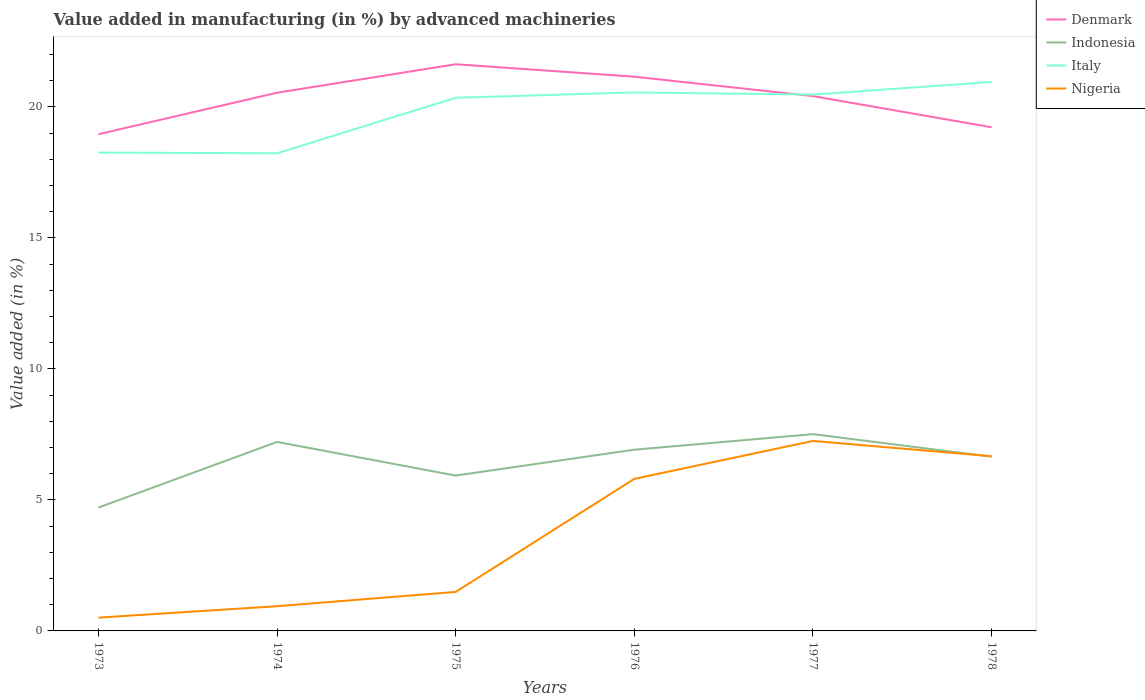Is the number of lines equal to the number of legend labels?
Your answer should be very brief. Yes. Across all years, what is the maximum percentage of value added in manufacturing by advanced machineries in Italy?
Keep it short and to the point. 18.23. What is the total percentage of value added in manufacturing by advanced machineries in Indonesia in the graph?
Provide a succinct answer. 0.27. What is the difference between the highest and the second highest percentage of value added in manufacturing by advanced machineries in Indonesia?
Offer a very short reply. 2.8. What is the difference between the highest and the lowest percentage of value added in manufacturing by advanced machineries in Denmark?
Your answer should be very brief. 4. Is the percentage of value added in manufacturing by advanced machineries in Italy strictly greater than the percentage of value added in manufacturing by advanced machineries in Nigeria over the years?
Keep it short and to the point. No. How many lines are there?
Give a very brief answer. 4. What is the difference between two consecutive major ticks on the Y-axis?
Offer a very short reply. 5. Does the graph contain any zero values?
Give a very brief answer. No. Does the graph contain grids?
Provide a succinct answer. No. Where does the legend appear in the graph?
Your answer should be compact. Top right. What is the title of the graph?
Provide a succinct answer. Value added in manufacturing (in %) by advanced machineries. Does "Mozambique" appear as one of the legend labels in the graph?
Make the answer very short. No. What is the label or title of the Y-axis?
Offer a very short reply. Value added (in %). What is the Value added (in %) in Denmark in 1973?
Your answer should be very brief. 18.95. What is the Value added (in %) in Indonesia in 1973?
Give a very brief answer. 4.71. What is the Value added (in %) of Italy in 1973?
Provide a succinct answer. 18.25. What is the Value added (in %) in Nigeria in 1973?
Your answer should be compact. 0.51. What is the Value added (in %) of Denmark in 1974?
Provide a succinct answer. 20.54. What is the Value added (in %) of Indonesia in 1974?
Offer a very short reply. 7.21. What is the Value added (in %) of Italy in 1974?
Provide a short and direct response. 18.23. What is the Value added (in %) of Nigeria in 1974?
Provide a succinct answer. 0.94. What is the Value added (in %) in Denmark in 1975?
Provide a short and direct response. 21.62. What is the Value added (in %) of Indonesia in 1975?
Offer a very short reply. 5.93. What is the Value added (in %) in Italy in 1975?
Your response must be concise. 20.34. What is the Value added (in %) in Nigeria in 1975?
Your answer should be compact. 1.49. What is the Value added (in %) of Denmark in 1976?
Keep it short and to the point. 21.15. What is the Value added (in %) of Indonesia in 1976?
Offer a terse response. 6.92. What is the Value added (in %) in Italy in 1976?
Provide a succinct answer. 20.55. What is the Value added (in %) of Nigeria in 1976?
Offer a terse response. 5.8. What is the Value added (in %) in Denmark in 1977?
Your response must be concise. 20.41. What is the Value added (in %) in Indonesia in 1977?
Ensure brevity in your answer.  7.51. What is the Value added (in %) in Italy in 1977?
Offer a terse response. 20.47. What is the Value added (in %) of Nigeria in 1977?
Ensure brevity in your answer.  7.25. What is the Value added (in %) of Denmark in 1978?
Your answer should be compact. 19.22. What is the Value added (in %) in Indonesia in 1978?
Offer a terse response. 6.65. What is the Value added (in %) of Italy in 1978?
Offer a very short reply. 20.95. What is the Value added (in %) of Nigeria in 1978?
Offer a very short reply. 6.67. Across all years, what is the maximum Value added (in %) in Denmark?
Your answer should be very brief. 21.62. Across all years, what is the maximum Value added (in %) in Indonesia?
Your answer should be very brief. 7.51. Across all years, what is the maximum Value added (in %) in Italy?
Keep it short and to the point. 20.95. Across all years, what is the maximum Value added (in %) in Nigeria?
Offer a very short reply. 7.25. Across all years, what is the minimum Value added (in %) in Denmark?
Ensure brevity in your answer.  18.95. Across all years, what is the minimum Value added (in %) of Indonesia?
Ensure brevity in your answer.  4.71. Across all years, what is the minimum Value added (in %) of Italy?
Provide a short and direct response. 18.23. Across all years, what is the minimum Value added (in %) in Nigeria?
Provide a succinct answer. 0.51. What is the total Value added (in %) in Denmark in the graph?
Give a very brief answer. 121.89. What is the total Value added (in %) of Indonesia in the graph?
Offer a terse response. 38.92. What is the total Value added (in %) in Italy in the graph?
Provide a succinct answer. 118.79. What is the total Value added (in %) in Nigeria in the graph?
Keep it short and to the point. 22.66. What is the difference between the Value added (in %) in Denmark in 1973 and that in 1974?
Provide a succinct answer. -1.58. What is the difference between the Value added (in %) in Indonesia in 1973 and that in 1974?
Make the answer very short. -2.51. What is the difference between the Value added (in %) of Italy in 1973 and that in 1974?
Provide a short and direct response. 0.03. What is the difference between the Value added (in %) of Nigeria in 1973 and that in 1974?
Make the answer very short. -0.44. What is the difference between the Value added (in %) of Denmark in 1973 and that in 1975?
Your answer should be very brief. -2.67. What is the difference between the Value added (in %) of Indonesia in 1973 and that in 1975?
Ensure brevity in your answer.  -1.22. What is the difference between the Value added (in %) in Italy in 1973 and that in 1975?
Offer a very short reply. -2.09. What is the difference between the Value added (in %) in Nigeria in 1973 and that in 1975?
Your response must be concise. -0.98. What is the difference between the Value added (in %) in Denmark in 1973 and that in 1976?
Offer a very short reply. -2.19. What is the difference between the Value added (in %) in Indonesia in 1973 and that in 1976?
Give a very brief answer. -2.21. What is the difference between the Value added (in %) of Italy in 1973 and that in 1976?
Your response must be concise. -2.29. What is the difference between the Value added (in %) of Nigeria in 1973 and that in 1976?
Your response must be concise. -5.3. What is the difference between the Value added (in %) in Denmark in 1973 and that in 1977?
Offer a terse response. -1.45. What is the difference between the Value added (in %) in Indonesia in 1973 and that in 1977?
Provide a succinct answer. -2.8. What is the difference between the Value added (in %) in Italy in 1973 and that in 1977?
Provide a short and direct response. -2.21. What is the difference between the Value added (in %) in Nigeria in 1973 and that in 1977?
Your answer should be compact. -6.74. What is the difference between the Value added (in %) in Denmark in 1973 and that in 1978?
Offer a very short reply. -0.26. What is the difference between the Value added (in %) in Indonesia in 1973 and that in 1978?
Keep it short and to the point. -1.94. What is the difference between the Value added (in %) in Italy in 1973 and that in 1978?
Offer a very short reply. -2.7. What is the difference between the Value added (in %) of Nigeria in 1973 and that in 1978?
Keep it short and to the point. -6.16. What is the difference between the Value added (in %) in Denmark in 1974 and that in 1975?
Provide a succinct answer. -1.09. What is the difference between the Value added (in %) of Indonesia in 1974 and that in 1975?
Give a very brief answer. 1.28. What is the difference between the Value added (in %) in Italy in 1974 and that in 1975?
Offer a very short reply. -2.12. What is the difference between the Value added (in %) in Nigeria in 1974 and that in 1975?
Make the answer very short. -0.55. What is the difference between the Value added (in %) of Denmark in 1974 and that in 1976?
Ensure brevity in your answer.  -0.61. What is the difference between the Value added (in %) of Indonesia in 1974 and that in 1976?
Your response must be concise. 0.3. What is the difference between the Value added (in %) of Italy in 1974 and that in 1976?
Give a very brief answer. -2.32. What is the difference between the Value added (in %) of Nigeria in 1974 and that in 1976?
Provide a short and direct response. -4.86. What is the difference between the Value added (in %) in Denmark in 1974 and that in 1977?
Give a very brief answer. 0.13. What is the difference between the Value added (in %) in Indonesia in 1974 and that in 1977?
Provide a short and direct response. -0.3. What is the difference between the Value added (in %) in Italy in 1974 and that in 1977?
Give a very brief answer. -2.24. What is the difference between the Value added (in %) in Nigeria in 1974 and that in 1977?
Make the answer very short. -6.31. What is the difference between the Value added (in %) of Denmark in 1974 and that in 1978?
Your answer should be compact. 1.32. What is the difference between the Value added (in %) of Indonesia in 1974 and that in 1978?
Keep it short and to the point. 0.56. What is the difference between the Value added (in %) of Italy in 1974 and that in 1978?
Give a very brief answer. -2.72. What is the difference between the Value added (in %) in Nigeria in 1974 and that in 1978?
Give a very brief answer. -5.72. What is the difference between the Value added (in %) of Denmark in 1975 and that in 1976?
Provide a succinct answer. 0.48. What is the difference between the Value added (in %) in Indonesia in 1975 and that in 1976?
Ensure brevity in your answer.  -0.99. What is the difference between the Value added (in %) in Italy in 1975 and that in 1976?
Provide a succinct answer. -0.2. What is the difference between the Value added (in %) in Nigeria in 1975 and that in 1976?
Offer a very short reply. -4.31. What is the difference between the Value added (in %) of Denmark in 1975 and that in 1977?
Ensure brevity in your answer.  1.22. What is the difference between the Value added (in %) in Indonesia in 1975 and that in 1977?
Ensure brevity in your answer.  -1.58. What is the difference between the Value added (in %) in Italy in 1975 and that in 1977?
Your answer should be compact. -0.12. What is the difference between the Value added (in %) of Nigeria in 1975 and that in 1977?
Your answer should be very brief. -5.76. What is the difference between the Value added (in %) of Denmark in 1975 and that in 1978?
Your response must be concise. 2.41. What is the difference between the Value added (in %) of Indonesia in 1975 and that in 1978?
Your response must be concise. -0.72. What is the difference between the Value added (in %) in Italy in 1975 and that in 1978?
Make the answer very short. -0.61. What is the difference between the Value added (in %) of Nigeria in 1975 and that in 1978?
Make the answer very short. -5.18. What is the difference between the Value added (in %) of Denmark in 1976 and that in 1977?
Ensure brevity in your answer.  0.74. What is the difference between the Value added (in %) of Indonesia in 1976 and that in 1977?
Provide a succinct answer. -0.59. What is the difference between the Value added (in %) of Italy in 1976 and that in 1977?
Make the answer very short. 0.08. What is the difference between the Value added (in %) in Nigeria in 1976 and that in 1977?
Provide a succinct answer. -1.45. What is the difference between the Value added (in %) of Denmark in 1976 and that in 1978?
Provide a short and direct response. 1.93. What is the difference between the Value added (in %) of Indonesia in 1976 and that in 1978?
Ensure brevity in your answer.  0.27. What is the difference between the Value added (in %) in Italy in 1976 and that in 1978?
Offer a very short reply. -0.4. What is the difference between the Value added (in %) in Nigeria in 1976 and that in 1978?
Offer a terse response. -0.86. What is the difference between the Value added (in %) in Denmark in 1977 and that in 1978?
Provide a succinct answer. 1.19. What is the difference between the Value added (in %) of Indonesia in 1977 and that in 1978?
Make the answer very short. 0.86. What is the difference between the Value added (in %) in Italy in 1977 and that in 1978?
Ensure brevity in your answer.  -0.48. What is the difference between the Value added (in %) of Nigeria in 1977 and that in 1978?
Keep it short and to the point. 0.58. What is the difference between the Value added (in %) of Denmark in 1973 and the Value added (in %) of Indonesia in 1974?
Provide a short and direct response. 11.74. What is the difference between the Value added (in %) in Denmark in 1973 and the Value added (in %) in Italy in 1974?
Your answer should be very brief. 0.73. What is the difference between the Value added (in %) of Denmark in 1973 and the Value added (in %) of Nigeria in 1974?
Your answer should be very brief. 18.01. What is the difference between the Value added (in %) in Indonesia in 1973 and the Value added (in %) in Italy in 1974?
Your answer should be very brief. -13.52. What is the difference between the Value added (in %) in Indonesia in 1973 and the Value added (in %) in Nigeria in 1974?
Make the answer very short. 3.76. What is the difference between the Value added (in %) in Italy in 1973 and the Value added (in %) in Nigeria in 1974?
Your response must be concise. 17.31. What is the difference between the Value added (in %) of Denmark in 1973 and the Value added (in %) of Indonesia in 1975?
Your answer should be very brief. 13.03. What is the difference between the Value added (in %) in Denmark in 1973 and the Value added (in %) in Italy in 1975?
Provide a short and direct response. -1.39. What is the difference between the Value added (in %) of Denmark in 1973 and the Value added (in %) of Nigeria in 1975?
Provide a succinct answer. 17.47. What is the difference between the Value added (in %) in Indonesia in 1973 and the Value added (in %) in Italy in 1975?
Provide a short and direct response. -15.64. What is the difference between the Value added (in %) in Indonesia in 1973 and the Value added (in %) in Nigeria in 1975?
Provide a succinct answer. 3.22. What is the difference between the Value added (in %) of Italy in 1973 and the Value added (in %) of Nigeria in 1975?
Keep it short and to the point. 16.77. What is the difference between the Value added (in %) of Denmark in 1973 and the Value added (in %) of Indonesia in 1976?
Offer a terse response. 12.04. What is the difference between the Value added (in %) of Denmark in 1973 and the Value added (in %) of Italy in 1976?
Provide a short and direct response. -1.59. What is the difference between the Value added (in %) in Denmark in 1973 and the Value added (in %) in Nigeria in 1976?
Provide a succinct answer. 13.15. What is the difference between the Value added (in %) of Indonesia in 1973 and the Value added (in %) of Italy in 1976?
Keep it short and to the point. -15.84. What is the difference between the Value added (in %) in Indonesia in 1973 and the Value added (in %) in Nigeria in 1976?
Provide a succinct answer. -1.1. What is the difference between the Value added (in %) of Italy in 1973 and the Value added (in %) of Nigeria in 1976?
Keep it short and to the point. 12.45. What is the difference between the Value added (in %) in Denmark in 1973 and the Value added (in %) in Indonesia in 1977?
Provide a short and direct response. 11.45. What is the difference between the Value added (in %) in Denmark in 1973 and the Value added (in %) in Italy in 1977?
Make the answer very short. -1.51. What is the difference between the Value added (in %) in Denmark in 1973 and the Value added (in %) in Nigeria in 1977?
Offer a very short reply. 11.71. What is the difference between the Value added (in %) in Indonesia in 1973 and the Value added (in %) in Italy in 1977?
Keep it short and to the point. -15.76. What is the difference between the Value added (in %) in Indonesia in 1973 and the Value added (in %) in Nigeria in 1977?
Your response must be concise. -2.54. What is the difference between the Value added (in %) in Italy in 1973 and the Value added (in %) in Nigeria in 1977?
Provide a short and direct response. 11. What is the difference between the Value added (in %) of Denmark in 1973 and the Value added (in %) of Indonesia in 1978?
Make the answer very short. 12.31. What is the difference between the Value added (in %) in Denmark in 1973 and the Value added (in %) in Italy in 1978?
Your answer should be very brief. -2. What is the difference between the Value added (in %) in Denmark in 1973 and the Value added (in %) in Nigeria in 1978?
Give a very brief answer. 12.29. What is the difference between the Value added (in %) of Indonesia in 1973 and the Value added (in %) of Italy in 1978?
Your response must be concise. -16.24. What is the difference between the Value added (in %) in Indonesia in 1973 and the Value added (in %) in Nigeria in 1978?
Ensure brevity in your answer.  -1.96. What is the difference between the Value added (in %) of Italy in 1973 and the Value added (in %) of Nigeria in 1978?
Make the answer very short. 11.59. What is the difference between the Value added (in %) of Denmark in 1974 and the Value added (in %) of Indonesia in 1975?
Offer a terse response. 14.61. What is the difference between the Value added (in %) of Denmark in 1974 and the Value added (in %) of Italy in 1975?
Offer a terse response. 0.19. What is the difference between the Value added (in %) of Denmark in 1974 and the Value added (in %) of Nigeria in 1975?
Offer a terse response. 19.05. What is the difference between the Value added (in %) of Indonesia in 1974 and the Value added (in %) of Italy in 1975?
Offer a very short reply. -13.13. What is the difference between the Value added (in %) in Indonesia in 1974 and the Value added (in %) in Nigeria in 1975?
Give a very brief answer. 5.72. What is the difference between the Value added (in %) of Italy in 1974 and the Value added (in %) of Nigeria in 1975?
Ensure brevity in your answer.  16.74. What is the difference between the Value added (in %) of Denmark in 1974 and the Value added (in %) of Indonesia in 1976?
Provide a short and direct response. 13.62. What is the difference between the Value added (in %) in Denmark in 1974 and the Value added (in %) in Italy in 1976?
Offer a terse response. -0.01. What is the difference between the Value added (in %) in Denmark in 1974 and the Value added (in %) in Nigeria in 1976?
Offer a terse response. 14.74. What is the difference between the Value added (in %) of Indonesia in 1974 and the Value added (in %) of Italy in 1976?
Offer a very short reply. -13.34. What is the difference between the Value added (in %) in Indonesia in 1974 and the Value added (in %) in Nigeria in 1976?
Provide a succinct answer. 1.41. What is the difference between the Value added (in %) of Italy in 1974 and the Value added (in %) of Nigeria in 1976?
Provide a succinct answer. 12.42. What is the difference between the Value added (in %) of Denmark in 1974 and the Value added (in %) of Indonesia in 1977?
Your response must be concise. 13.03. What is the difference between the Value added (in %) of Denmark in 1974 and the Value added (in %) of Italy in 1977?
Ensure brevity in your answer.  0.07. What is the difference between the Value added (in %) in Denmark in 1974 and the Value added (in %) in Nigeria in 1977?
Keep it short and to the point. 13.29. What is the difference between the Value added (in %) of Indonesia in 1974 and the Value added (in %) of Italy in 1977?
Give a very brief answer. -13.26. What is the difference between the Value added (in %) in Indonesia in 1974 and the Value added (in %) in Nigeria in 1977?
Your answer should be very brief. -0.04. What is the difference between the Value added (in %) of Italy in 1974 and the Value added (in %) of Nigeria in 1977?
Keep it short and to the point. 10.98. What is the difference between the Value added (in %) in Denmark in 1974 and the Value added (in %) in Indonesia in 1978?
Offer a very short reply. 13.89. What is the difference between the Value added (in %) in Denmark in 1974 and the Value added (in %) in Italy in 1978?
Provide a short and direct response. -0.41. What is the difference between the Value added (in %) in Denmark in 1974 and the Value added (in %) in Nigeria in 1978?
Keep it short and to the point. 13.87. What is the difference between the Value added (in %) of Indonesia in 1974 and the Value added (in %) of Italy in 1978?
Ensure brevity in your answer.  -13.74. What is the difference between the Value added (in %) of Indonesia in 1974 and the Value added (in %) of Nigeria in 1978?
Provide a short and direct response. 0.55. What is the difference between the Value added (in %) in Italy in 1974 and the Value added (in %) in Nigeria in 1978?
Your answer should be compact. 11.56. What is the difference between the Value added (in %) in Denmark in 1975 and the Value added (in %) in Indonesia in 1976?
Your answer should be very brief. 14.71. What is the difference between the Value added (in %) of Denmark in 1975 and the Value added (in %) of Italy in 1976?
Provide a succinct answer. 1.08. What is the difference between the Value added (in %) of Denmark in 1975 and the Value added (in %) of Nigeria in 1976?
Offer a terse response. 15.82. What is the difference between the Value added (in %) in Indonesia in 1975 and the Value added (in %) in Italy in 1976?
Your answer should be very brief. -14.62. What is the difference between the Value added (in %) in Indonesia in 1975 and the Value added (in %) in Nigeria in 1976?
Your response must be concise. 0.13. What is the difference between the Value added (in %) of Italy in 1975 and the Value added (in %) of Nigeria in 1976?
Offer a very short reply. 14.54. What is the difference between the Value added (in %) in Denmark in 1975 and the Value added (in %) in Indonesia in 1977?
Ensure brevity in your answer.  14.12. What is the difference between the Value added (in %) in Denmark in 1975 and the Value added (in %) in Italy in 1977?
Keep it short and to the point. 1.16. What is the difference between the Value added (in %) in Denmark in 1975 and the Value added (in %) in Nigeria in 1977?
Ensure brevity in your answer.  14.38. What is the difference between the Value added (in %) of Indonesia in 1975 and the Value added (in %) of Italy in 1977?
Your response must be concise. -14.54. What is the difference between the Value added (in %) of Indonesia in 1975 and the Value added (in %) of Nigeria in 1977?
Keep it short and to the point. -1.32. What is the difference between the Value added (in %) in Italy in 1975 and the Value added (in %) in Nigeria in 1977?
Offer a terse response. 13.1. What is the difference between the Value added (in %) of Denmark in 1975 and the Value added (in %) of Indonesia in 1978?
Ensure brevity in your answer.  14.98. What is the difference between the Value added (in %) in Denmark in 1975 and the Value added (in %) in Italy in 1978?
Keep it short and to the point. 0.67. What is the difference between the Value added (in %) in Denmark in 1975 and the Value added (in %) in Nigeria in 1978?
Give a very brief answer. 14.96. What is the difference between the Value added (in %) in Indonesia in 1975 and the Value added (in %) in Italy in 1978?
Your answer should be compact. -15.02. What is the difference between the Value added (in %) in Indonesia in 1975 and the Value added (in %) in Nigeria in 1978?
Keep it short and to the point. -0.74. What is the difference between the Value added (in %) in Italy in 1975 and the Value added (in %) in Nigeria in 1978?
Provide a succinct answer. 13.68. What is the difference between the Value added (in %) of Denmark in 1976 and the Value added (in %) of Indonesia in 1977?
Offer a very short reply. 13.64. What is the difference between the Value added (in %) of Denmark in 1976 and the Value added (in %) of Italy in 1977?
Offer a very short reply. 0.68. What is the difference between the Value added (in %) of Denmark in 1976 and the Value added (in %) of Nigeria in 1977?
Your answer should be compact. 13.9. What is the difference between the Value added (in %) of Indonesia in 1976 and the Value added (in %) of Italy in 1977?
Your response must be concise. -13.55. What is the difference between the Value added (in %) in Indonesia in 1976 and the Value added (in %) in Nigeria in 1977?
Your response must be concise. -0.33. What is the difference between the Value added (in %) of Italy in 1976 and the Value added (in %) of Nigeria in 1977?
Your answer should be compact. 13.3. What is the difference between the Value added (in %) in Denmark in 1976 and the Value added (in %) in Indonesia in 1978?
Make the answer very short. 14.5. What is the difference between the Value added (in %) in Denmark in 1976 and the Value added (in %) in Italy in 1978?
Give a very brief answer. 0.2. What is the difference between the Value added (in %) in Denmark in 1976 and the Value added (in %) in Nigeria in 1978?
Give a very brief answer. 14.48. What is the difference between the Value added (in %) in Indonesia in 1976 and the Value added (in %) in Italy in 1978?
Your response must be concise. -14.04. What is the difference between the Value added (in %) in Indonesia in 1976 and the Value added (in %) in Nigeria in 1978?
Offer a very short reply. 0.25. What is the difference between the Value added (in %) in Italy in 1976 and the Value added (in %) in Nigeria in 1978?
Ensure brevity in your answer.  13.88. What is the difference between the Value added (in %) in Denmark in 1977 and the Value added (in %) in Indonesia in 1978?
Keep it short and to the point. 13.76. What is the difference between the Value added (in %) of Denmark in 1977 and the Value added (in %) of Italy in 1978?
Provide a succinct answer. -0.54. What is the difference between the Value added (in %) of Denmark in 1977 and the Value added (in %) of Nigeria in 1978?
Make the answer very short. 13.74. What is the difference between the Value added (in %) of Indonesia in 1977 and the Value added (in %) of Italy in 1978?
Your response must be concise. -13.44. What is the difference between the Value added (in %) of Indonesia in 1977 and the Value added (in %) of Nigeria in 1978?
Give a very brief answer. 0.84. What is the difference between the Value added (in %) in Italy in 1977 and the Value added (in %) in Nigeria in 1978?
Your answer should be very brief. 13.8. What is the average Value added (in %) of Denmark per year?
Your answer should be compact. 20.32. What is the average Value added (in %) of Indonesia per year?
Your response must be concise. 6.49. What is the average Value added (in %) of Italy per year?
Offer a terse response. 19.8. What is the average Value added (in %) in Nigeria per year?
Make the answer very short. 3.78. In the year 1973, what is the difference between the Value added (in %) of Denmark and Value added (in %) of Indonesia?
Give a very brief answer. 14.25. In the year 1973, what is the difference between the Value added (in %) of Denmark and Value added (in %) of Italy?
Offer a very short reply. 0.7. In the year 1973, what is the difference between the Value added (in %) in Denmark and Value added (in %) in Nigeria?
Give a very brief answer. 18.45. In the year 1973, what is the difference between the Value added (in %) of Indonesia and Value added (in %) of Italy?
Offer a terse response. -13.55. In the year 1973, what is the difference between the Value added (in %) in Indonesia and Value added (in %) in Nigeria?
Give a very brief answer. 4.2. In the year 1973, what is the difference between the Value added (in %) in Italy and Value added (in %) in Nigeria?
Give a very brief answer. 17.75. In the year 1974, what is the difference between the Value added (in %) in Denmark and Value added (in %) in Indonesia?
Your answer should be very brief. 13.33. In the year 1974, what is the difference between the Value added (in %) in Denmark and Value added (in %) in Italy?
Your response must be concise. 2.31. In the year 1974, what is the difference between the Value added (in %) of Denmark and Value added (in %) of Nigeria?
Ensure brevity in your answer.  19.59. In the year 1974, what is the difference between the Value added (in %) of Indonesia and Value added (in %) of Italy?
Your answer should be very brief. -11.02. In the year 1974, what is the difference between the Value added (in %) in Indonesia and Value added (in %) in Nigeria?
Ensure brevity in your answer.  6.27. In the year 1974, what is the difference between the Value added (in %) of Italy and Value added (in %) of Nigeria?
Give a very brief answer. 17.28. In the year 1975, what is the difference between the Value added (in %) in Denmark and Value added (in %) in Indonesia?
Ensure brevity in your answer.  15.7. In the year 1975, what is the difference between the Value added (in %) in Denmark and Value added (in %) in Italy?
Your response must be concise. 1.28. In the year 1975, what is the difference between the Value added (in %) of Denmark and Value added (in %) of Nigeria?
Offer a terse response. 20.14. In the year 1975, what is the difference between the Value added (in %) in Indonesia and Value added (in %) in Italy?
Your answer should be compact. -14.42. In the year 1975, what is the difference between the Value added (in %) of Indonesia and Value added (in %) of Nigeria?
Provide a short and direct response. 4.44. In the year 1975, what is the difference between the Value added (in %) in Italy and Value added (in %) in Nigeria?
Your answer should be very brief. 18.86. In the year 1976, what is the difference between the Value added (in %) in Denmark and Value added (in %) in Indonesia?
Provide a succinct answer. 14.23. In the year 1976, what is the difference between the Value added (in %) of Denmark and Value added (in %) of Italy?
Your response must be concise. 0.6. In the year 1976, what is the difference between the Value added (in %) of Denmark and Value added (in %) of Nigeria?
Give a very brief answer. 15.35. In the year 1976, what is the difference between the Value added (in %) of Indonesia and Value added (in %) of Italy?
Provide a succinct answer. -13.63. In the year 1976, what is the difference between the Value added (in %) of Indonesia and Value added (in %) of Nigeria?
Give a very brief answer. 1.11. In the year 1976, what is the difference between the Value added (in %) in Italy and Value added (in %) in Nigeria?
Provide a short and direct response. 14.75. In the year 1977, what is the difference between the Value added (in %) of Denmark and Value added (in %) of Indonesia?
Your response must be concise. 12.9. In the year 1977, what is the difference between the Value added (in %) of Denmark and Value added (in %) of Italy?
Offer a very short reply. -0.06. In the year 1977, what is the difference between the Value added (in %) of Denmark and Value added (in %) of Nigeria?
Make the answer very short. 13.16. In the year 1977, what is the difference between the Value added (in %) of Indonesia and Value added (in %) of Italy?
Your answer should be very brief. -12.96. In the year 1977, what is the difference between the Value added (in %) in Indonesia and Value added (in %) in Nigeria?
Your answer should be very brief. 0.26. In the year 1977, what is the difference between the Value added (in %) of Italy and Value added (in %) of Nigeria?
Offer a very short reply. 13.22. In the year 1978, what is the difference between the Value added (in %) in Denmark and Value added (in %) in Indonesia?
Give a very brief answer. 12.57. In the year 1978, what is the difference between the Value added (in %) of Denmark and Value added (in %) of Italy?
Keep it short and to the point. -1.73. In the year 1978, what is the difference between the Value added (in %) of Denmark and Value added (in %) of Nigeria?
Make the answer very short. 12.55. In the year 1978, what is the difference between the Value added (in %) of Indonesia and Value added (in %) of Italy?
Offer a terse response. -14.3. In the year 1978, what is the difference between the Value added (in %) of Indonesia and Value added (in %) of Nigeria?
Your answer should be very brief. -0.02. In the year 1978, what is the difference between the Value added (in %) of Italy and Value added (in %) of Nigeria?
Make the answer very short. 14.28. What is the ratio of the Value added (in %) of Denmark in 1973 to that in 1974?
Provide a short and direct response. 0.92. What is the ratio of the Value added (in %) in Indonesia in 1973 to that in 1974?
Give a very brief answer. 0.65. What is the ratio of the Value added (in %) of Italy in 1973 to that in 1974?
Your answer should be very brief. 1. What is the ratio of the Value added (in %) of Nigeria in 1973 to that in 1974?
Make the answer very short. 0.54. What is the ratio of the Value added (in %) in Denmark in 1973 to that in 1975?
Provide a short and direct response. 0.88. What is the ratio of the Value added (in %) of Indonesia in 1973 to that in 1975?
Make the answer very short. 0.79. What is the ratio of the Value added (in %) of Italy in 1973 to that in 1975?
Provide a short and direct response. 0.9. What is the ratio of the Value added (in %) of Nigeria in 1973 to that in 1975?
Offer a very short reply. 0.34. What is the ratio of the Value added (in %) of Denmark in 1973 to that in 1976?
Your answer should be compact. 0.9. What is the ratio of the Value added (in %) of Indonesia in 1973 to that in 1976?
Provide a succinct answer. 0.68. What is the ratio of the Value added (in %) of Italy in 1973 to that in 1976?
Your response must be concise. 0.89. What is the ratio of the Value added (in %) in Nigeria in 1973 to that in 1976?
Give a very brief answer. 0.09. What is the ratio of the Value added (in %) of Denmark in 1973 to that in 1977?
Offer a terse response. 0.93. What is the ratio of the Value added (in %) in Indonesia in 1973 to that in 1977?
Give a very brief answer. 0.63. What is the ratio of the Value added (in %) of Italy in 1973 to that in 1977?
Offer a very short reply. 0.89. What is the ratio of the Value added (in %) in Nigeria in 1973 to that in 1977?
Offer a terse response. 0.07. What is the ratio of the Value added (in %) in Denmark in 1973 to that in 1978?
Offer a terse response. 0.99. What is the ratio of the Value added (in %) of Indonesia in 1973 to that in 1978?
Your response must be concise. 0.71. What is the ratio of the Value added (in %) of Italy in 1973 to that in 1978?
Ensure brevity in your answer.  0.87. What is the ratio of the Value added (in %) in Nigeria in 1973 to that in 1978?
Give a very brief answer. 0.08. What is the ratio of the Value added (in %) of Denmark in 1974 to that in 1975?
Your answer should be very brief. 0.95. What is the ratio of the Value added (in %) in Indonesia in 1974 to that in 1975?
Your answer should be compact. 1.22. What is the ratio of the Value added (in %) in Italy in 1974 to that in 1975?
Your answer should be compact. 0.9. What is the ratio of the Value added (in %) of Nigeria in 1974 to that in 1975?
Offer a very short reply. 0.63. What is the ratio of the Value added (in %) of Denmark in 1974 to that in 1976?
Your answer should be compact. 0.97. What is the ratio of the Value added (in %) in Indonesia in 1974 to that in 1976?
Provide a succinct answer. 1.04. What is the ratio of the Value added (in %) in Italy in 1974 to that in 1976?
Your answer should be very brief. 0.89. What is the ratio of the Value added (in %) of Nigeria in 1974 to that in 1976?
Your response must be concise. 0.16. What is the ratio of the Value added (in %) of Denmark in 1974 to that in 1977?
Offer a terse response. 1.01. What is the ratio of the Value added (in %) of Indonesia in 1974 to that in 1977?
Give a very brief answer. 0.96. What is the ratio of the Value added (in %) in Italy in 1974 to that in 1977?
Ensure brevity in your answer.  0.89. What is the ratio of the Value added (in %) of Nigeria in 1974 to that in 1977?
Give a very brief answer. 0.13. What is the ratio of the Value added (in %) in Denmark in 1974 to that in 1978?
Ensure brevity in your answer.  1.07. What is the ratio of the Value added (in %) of Indonesia in 1974 to that in 1978?
Make the answer very short. 1.08. What is the ratio of the Value added (in %) in Italy in 1974 to that in 1978?
Your response must be concise. 0.87. What is the ratio of the Value added (in %) in Nigeria in 1974 to that in 1978?
Provide a succinct answer. 0.14. What is the ratio of the Value added (in %) of Denmark in 1975 to that in 1976?
Offer a very short reply. 1.02. What is the ratio of the Value added (in %) of Indonesia in 1975 to that in 1976?
Your response must be concise. 0.86. What is the ratio of the Value added (in %) of Nigeria in 1975 to that in 1976?
Make the answer very short. 0.26. What is the ratio of the Value added (in %) of Denmark in 1975 to that in 1977?
Ensure brevity in your answer.  1.06. What is the ratio of the Value added (in %) of Indonesia in 1975 to that in 1977?
Your response must be concise. 0.79. What is the ratio of the Value added (in %) in Italy in 1975 to that in 1977?
Provide a succinct answer. 0.99. What is the ratio of the Value added (in %) of Nigeria in 1975 to that in 1977?
Keep it short and to the point. 0.21. What is the ratio of the Value added (in %) of Denmark in 1975 to that in 1978?
Your response must be concise. 1.13. What is the ratio of the Value added (in %) in Indonesia in 1975 to that in 1978?
Offer a very short reply. 0.89. What is the ratio of the Value added (in %) of Italy in 1975 to that in 1978?
Your answer should be very brief. 0.97. What is the ratio of the Value added (in %) in Nigeria in 1975 to that in 1978?
Your response must be concise. 0.22. What is the ratio of the Value added (in %) of Denmark in 1976 to that in 1977?
Provide a succinct answer. 1.04. What is the ratio of the Value added (in %) in Indonesia in 1976 to that in 1977?
Make the answer very short. 0.92. What is the ratio of the Value added (in %) in Nigeria in 1976 to that in 1977?
Keep it short and to the point. 0.8. What is the ratio of the Value added (in %) in Denmark in 1976 to that in 1978?
Give a very brief answer. 1.1. What is the ratio of the Value added (in %) of Indonesia in 1976 to that in 1978?
Provide a short and direct response. 1.04. What is the ratio of the Value added (in %) in Italy in 1976 to that in 1978?
Your response must be concise. 0.98. What is the ratio of the Value added (in %) of Nigeria in 1976 to that in 1978?
Keep it short and to the point. 0.87. What is the ratio of the Value added (in %) of Denmark in 1977 to that in 1978?
Your answer should be very brief. 1.06. What is the ratio of the Value added (in %) of Indonesia in 1977 to that in 1978?
Offer a terse response. 1.13. What is the ratio of the Value added (in %) in Italy in 1977 to that in 1978?
Ensure brevity in your answer.  0.98. What is the ratio of the Value added (in %) in Nigeria in 1977 to that in 1978?
Ensure brevity in your answer.  1.09. What is the difference between the highest and the second highest Value added (in %) of Denmark?
Your answer should be very brief. 0.48. What is the difference between the highest and the second highest Value added (in %) of Indonesia?
Provide a short and direct response. 0.3. What is the difference between the highest and the second highest Value added (in %) in Italy?
Offer a very short reply. 0.4. What is the difference between the highest and the second highest Value added (in %) of Nigeria?
Your response must be concise. 0.58. What is the difference between the highest and the lowest Value added (in %) in Denmark?
Your response must be concise. 2.67. What is the difference between the highest and the lowest Value added (in %) of Indonesia?
Give a very brief answer. 2.8. What is the difference between the highest and the lowest Value added (in %) in Italy?
Your response must be concise. 2.72. What is the difference between the highest and the lowest Value added (in %) of Nigeria?
Your response must be concise. 6.74. 